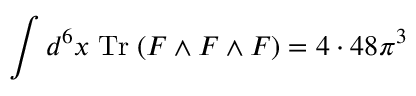Convert formula to latex. <formula><loc_0><loc_0><loc_500><loc_500>\int d ^ { 6 } x \, T r \, ( F \wedge F \wedge F ) = 4 \cdot 4 8 \pi ^ { 3 }</formula> 